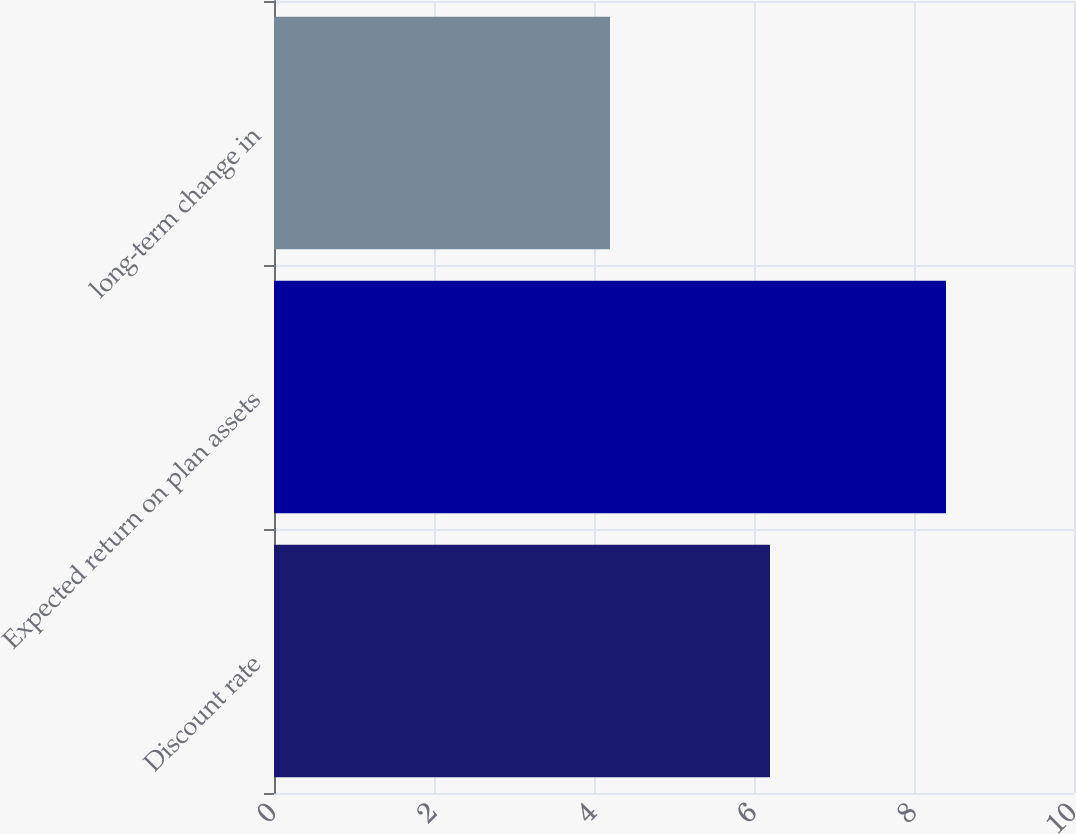Convert chart to OTSL. <chart><loc_0><loc_0><loc_500><loc_500><bar_chart><fcel>Discount rate<fcel>Expected return on plan assets<fcel>long-term change in<nl><fcel>6.2<fcel>8.4<fcel>4.2<nl></chart> 